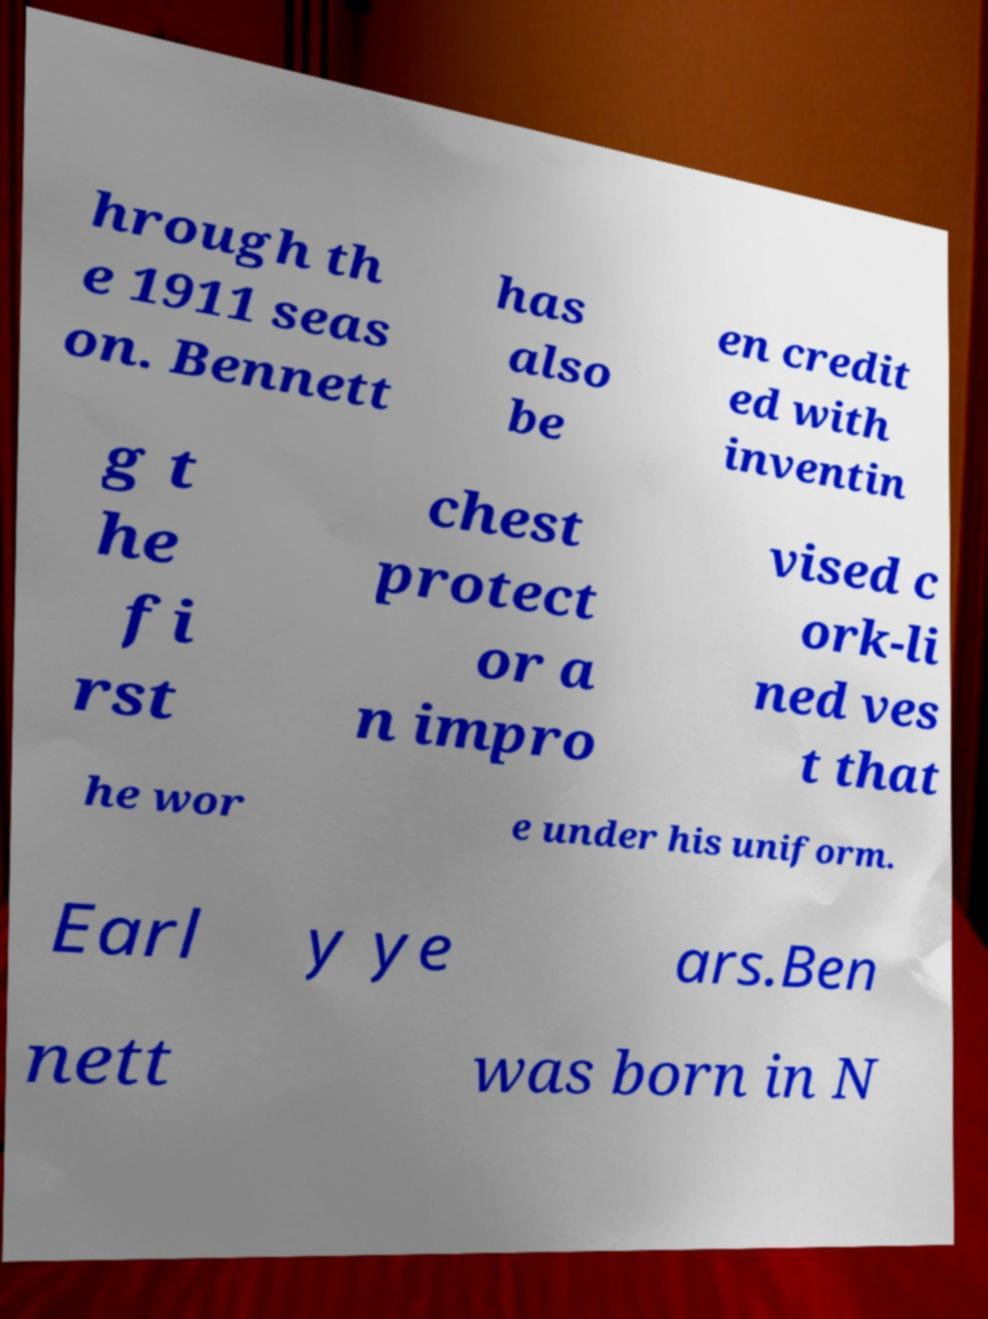I need the written content from this picture converted into text. Can you do that? hrough th e 1911 seas on. Bennett has also be en credit ed with inventin g t he fi rst chest protect or a n impro vised c ork-li ned ves t that he wor e under his uniform. Earl y ye ars.Ben nett was born in N 